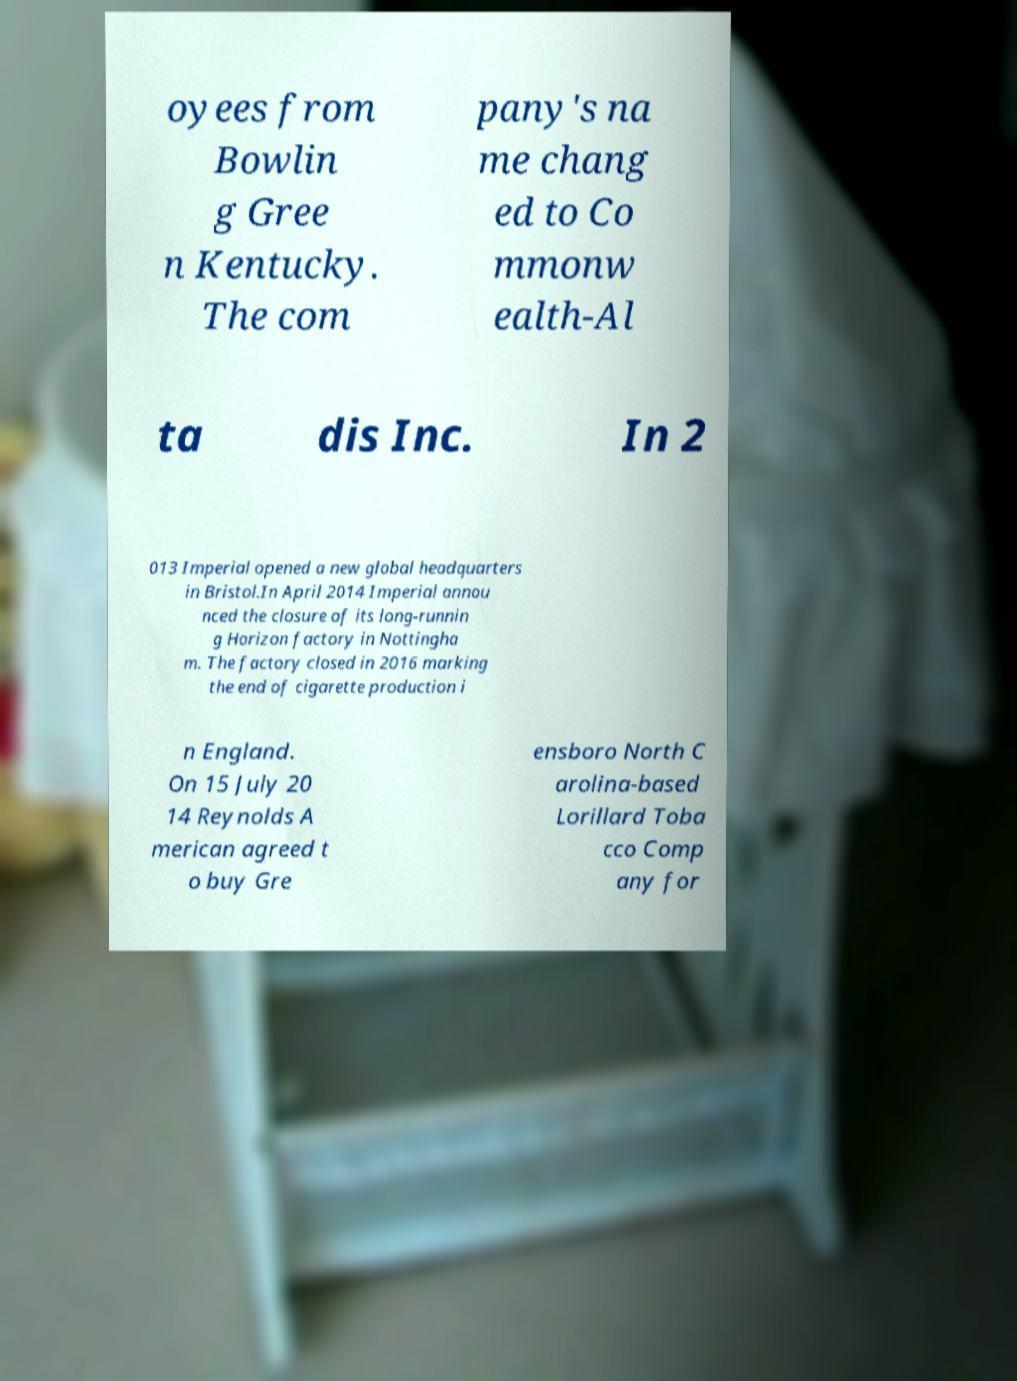Can you read and provide the text displayed in the image?This photo seems to have some interesting text. Can you extract and type it out for me? oyees from Bowlin g Gree n Kentucky. The com pany's na me chang ed to Co mmonw ealth-Al ta dis Inc. In 2 013 Imperial opened a new global headquarters in Bristol.In April 2014 Imperial annou nced the closure of its long-runnin g Horizon factory in Nottingha m. The factory closed in 2016 marking the end of cigarette production i n England. On 15 July 20 14 Reynolds A merican agreed t o buy Gre ensboro North C arolina-based Lorillard Toba cco Comp any for 